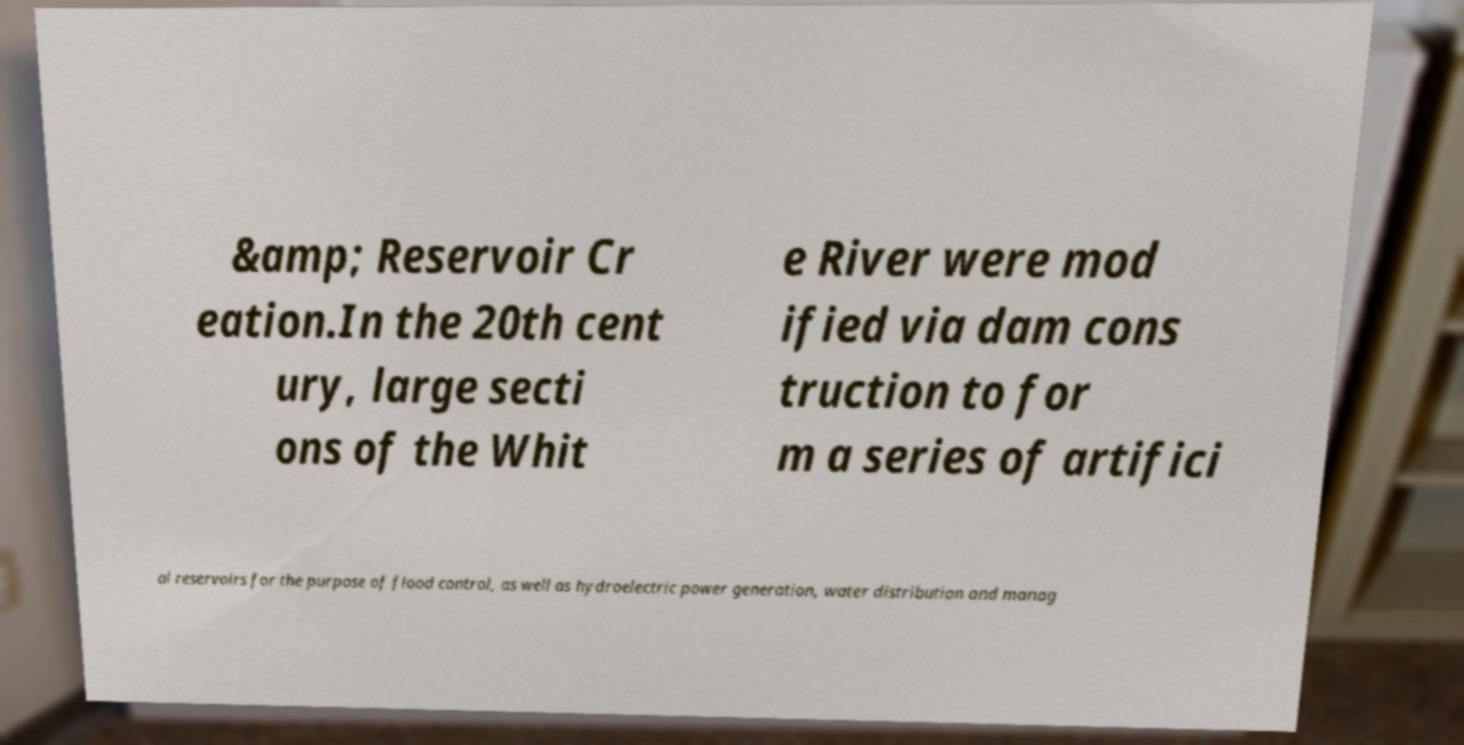What messages or text are displayed in this image? I need them in a readable, typed format. &amp; Reservoir Cr eation.In the 20th cent ury, large secti ons of the Whit e River were mod ified via dam cons truction to for m a series of artifici al reservoirs for the purpose of flood control, as well as hydroelectric power generation, water distribution and manag 